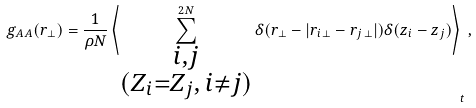<formula> <loc_0><loc_0><loc_500><loc_500>g _ { A A } ( r _ { \perp } ) = \frac { 1 } { \rho N } \left \langle \sum _ { \substack { i , j \\ ( Z _ { i } = Z _ { j } , \, i \ne j ) } } ^ { 2 N } \delta ( r _ { \perp } - | r _ { i \, \perp } - r _ { j \, \perp } | ) \delta ( z _ { i } - z _ { j } ) \right \rangle _ { t } ,</formula> 